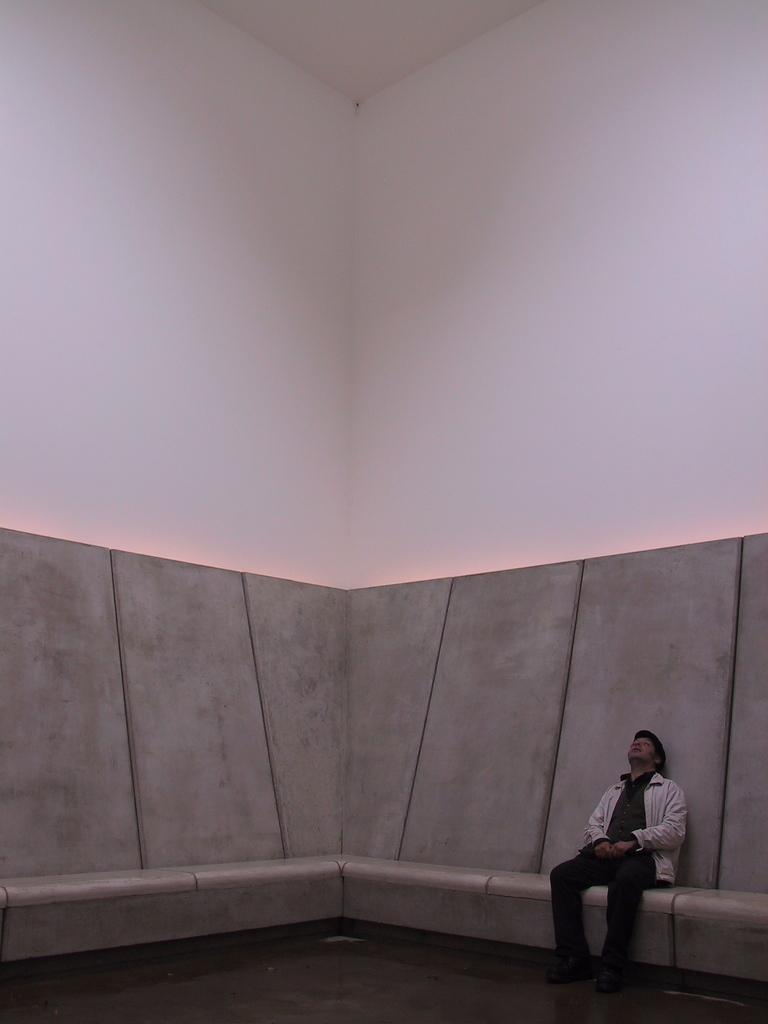What is the person in the image doing? The person is sitting on the right side of the image. What can be seen behind the person? There is a wall in the background of the image. What is visible at the bottom of the image? There is a floor visible at the bottom of the image. What type of ring can be seen on the person's finger in the image? There is no ring visible on the person's finger in the image. What kind of clouds can be seen in the image? There are no clouds present in the image; it features a person sitting on the right side with a wall in the background and a floor visible at the bottom. 